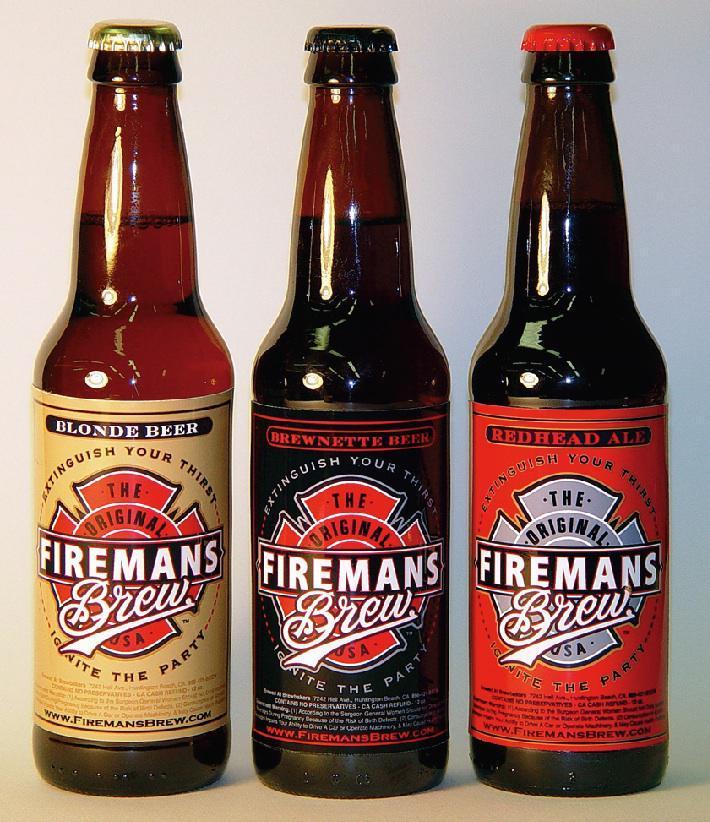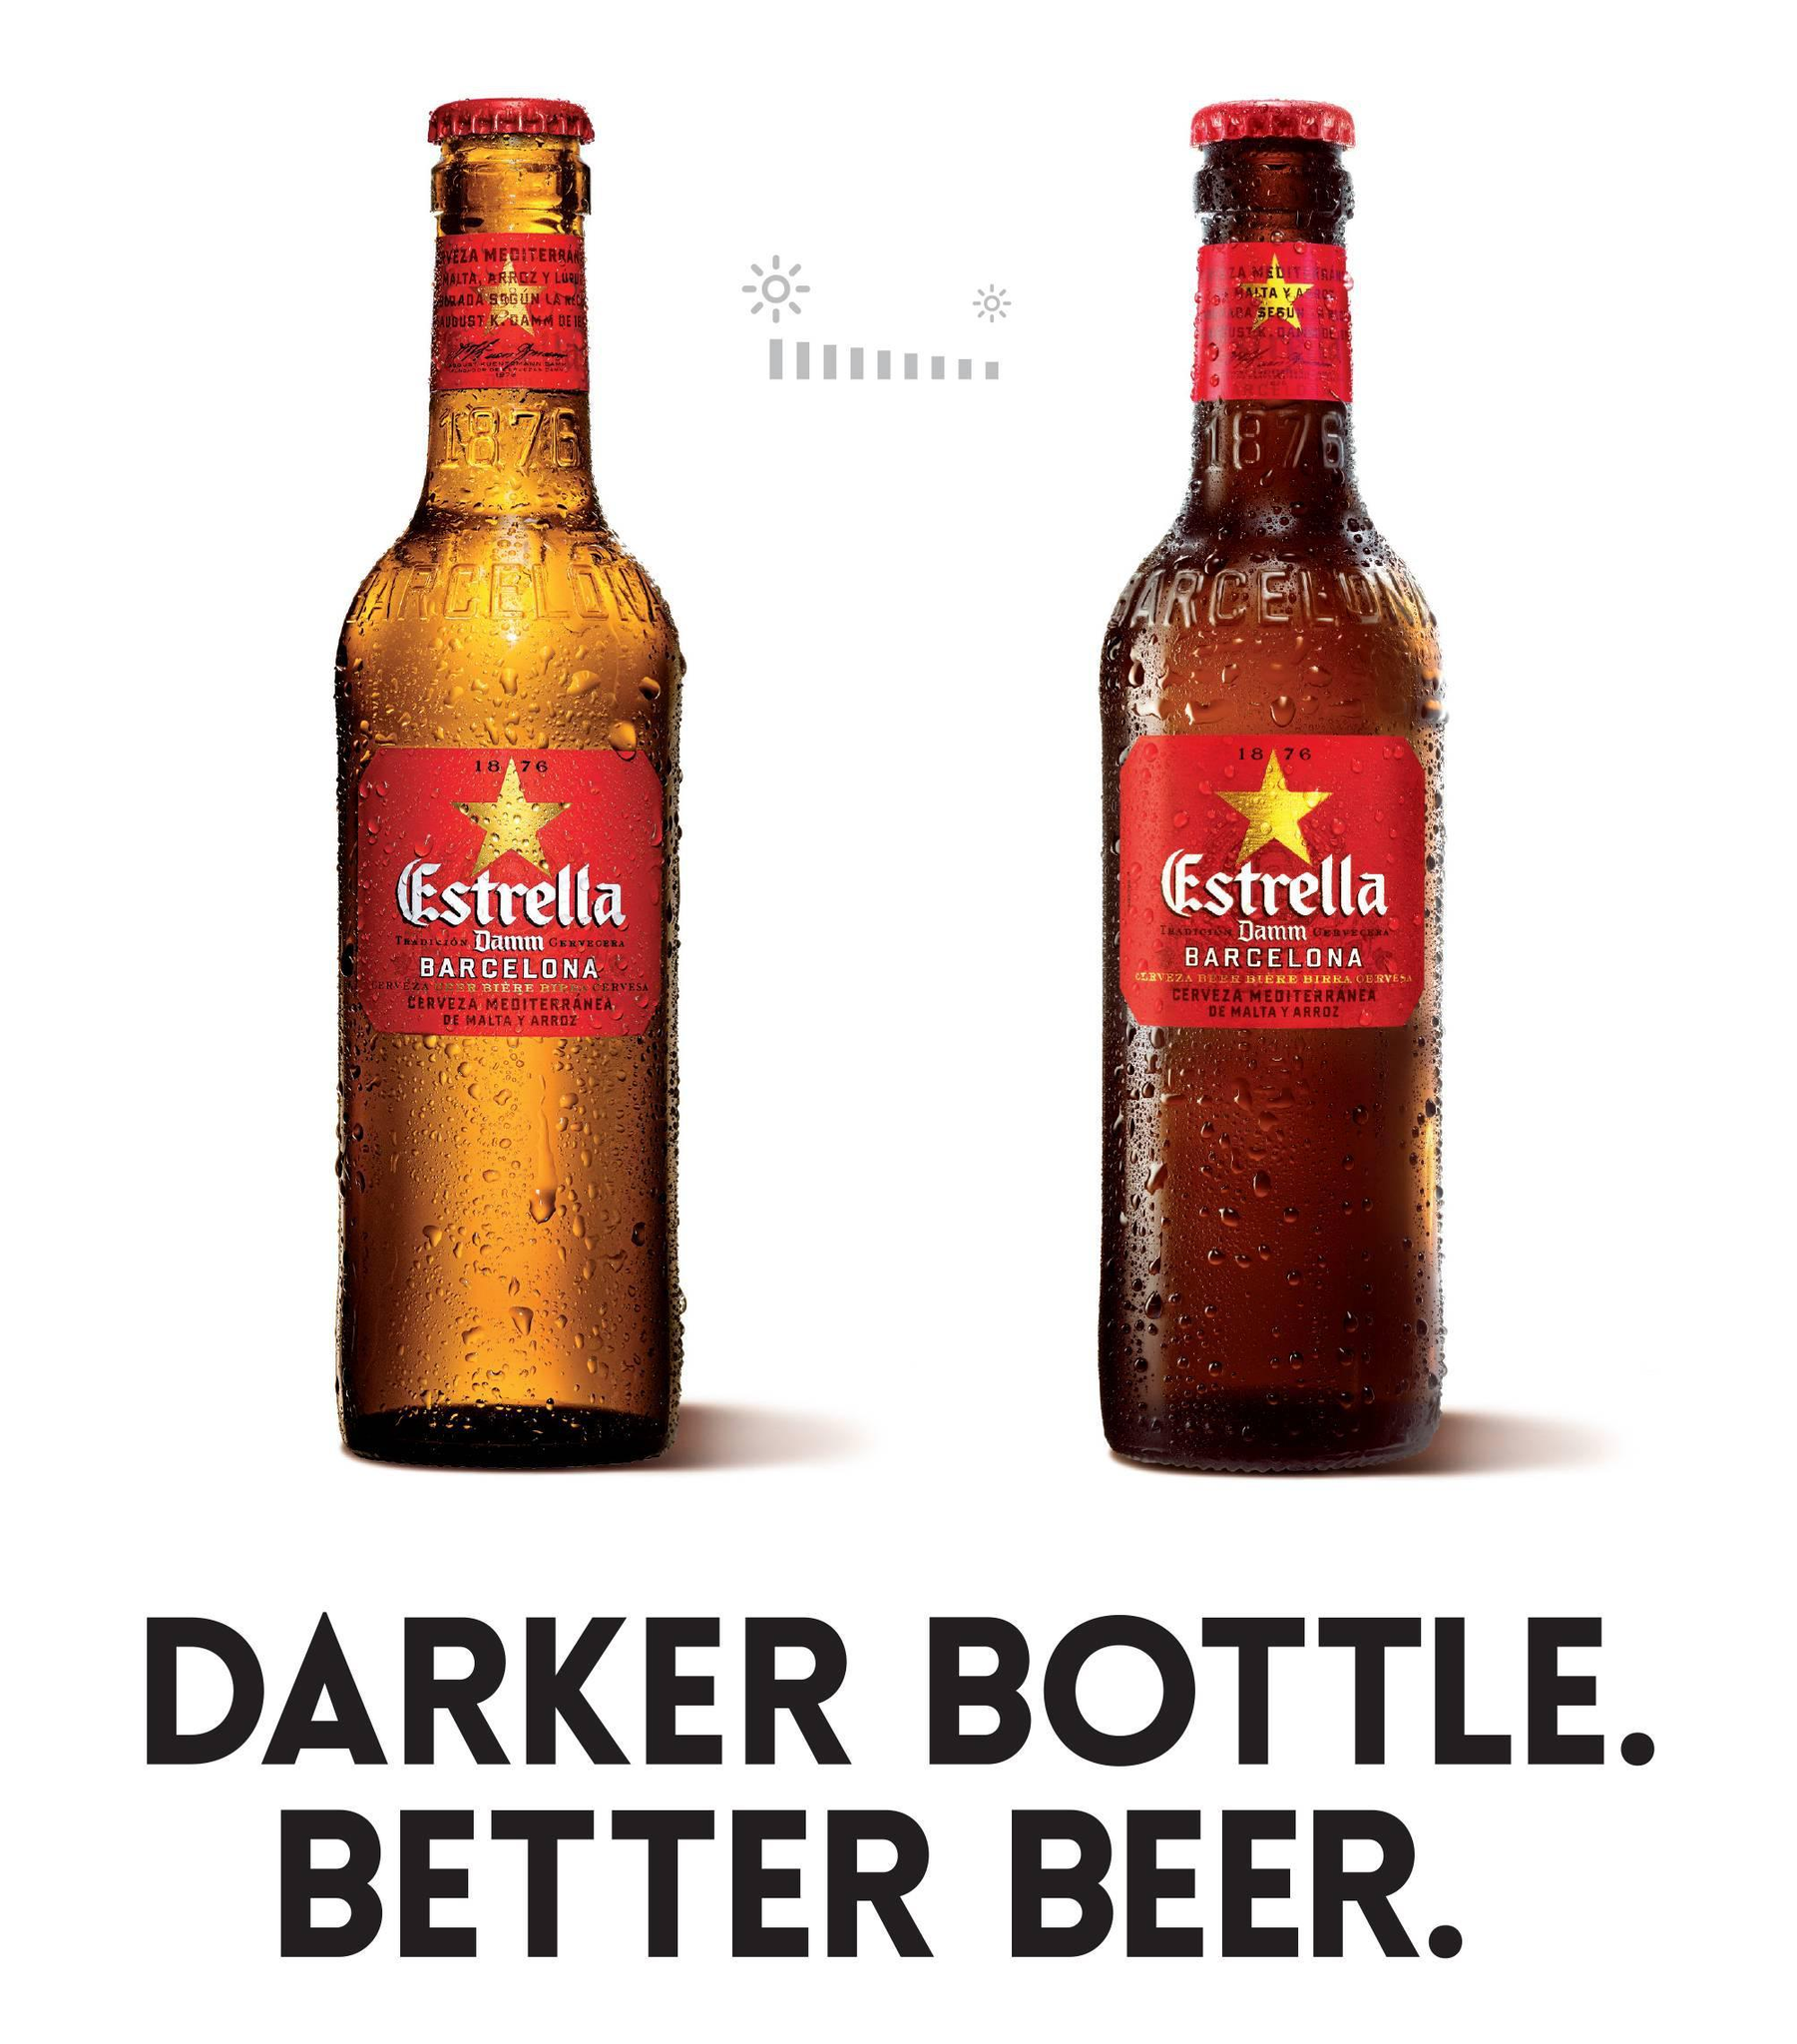The first image is the image on the left, the second image is the image on the right. Analyze the images presented: Is the assertion "Right and left images show the same number of bottles." valid? Answer yes or no. No. The first image is the image on the left, the second image is the image on the right. For the images shown, is this caption "There are no more than five beer bottles" true? Answer yes or no. Yes. 